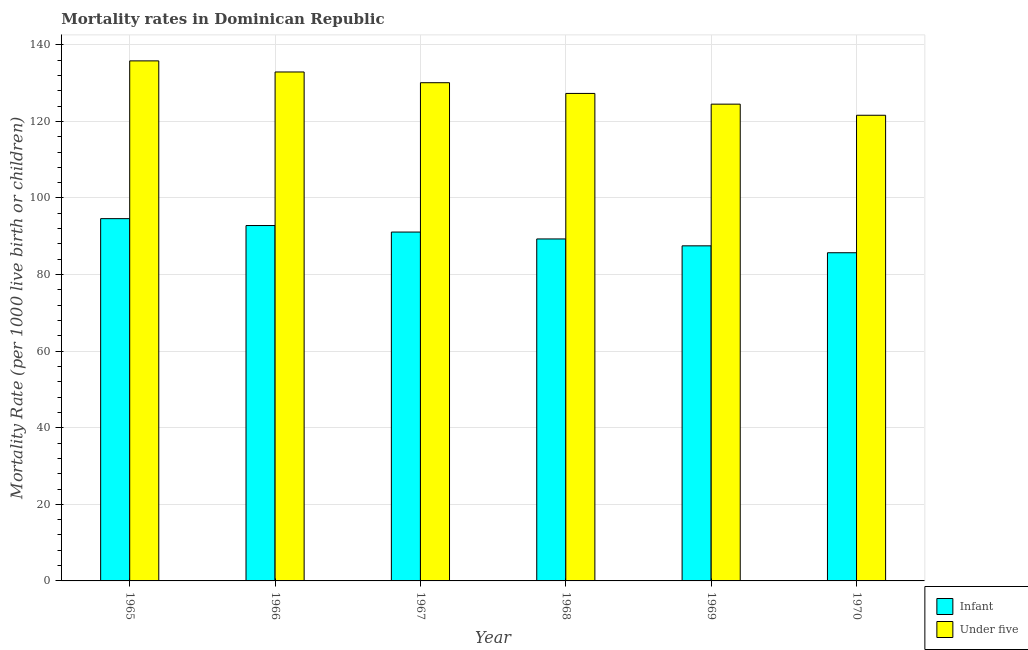How many bars are there on the 6th tick from the right?
Give a very brief answer. 2. What is the label of the 3rd group of bars from the left?
Your answer should be compact. 1967. What is the infant mortality rate in 1969?
Ensure brevity in your answer.  87.5. Across all years, what is the maximum under-5 mortality rate?
Provide a succinct answer. 135.8. Across all years, what is the minimum under-5 mortality rate?
Keep it short and to the point. 121.6. In which year was the infant mortality rate maximum?
Provide a succinct answer. 1965. What is the total under-5 mortality rate in the graph?
Offer a very short reply. 772.2. What is the difference between the under-5 mortality rate in 1966 and that in 1967?
Make the answer very short. 2.8. What is the difference between the infant mortality rate in 1966 and the under-5 mortality rate in 1967?
Offer a very short reply. 1.7. What is the average infant mortality rate per year?
Provide a succinct answer. 90.17. What is the ratio of the under-5 mortality rate in 1966 to that in 1969?
Give a very brief answer. 1.07. What is the difference between the highest and the second highest under-5 mortality rate?
Offer a very short reply. 2.9. What is the difference between the highest and the lowest infant mortality rate?
Offer a terse response. 8.9. What does the 2nd bar from the left in 1968 represents?
Provide a succinct answer. Under five. What does the 2nd bar from the right in 1966 represents?
Offer a terse response. Infant. How many years are there in the graph?
Give a very brief answer. 6. What is the difference between two consecutive major ticks on the Y-axis?
Your answer should be very brief. 20. Are the values on the major ticks of Y-axis written in scientific E-notation?
Offer a very short reply. No. Does the graph contain any zero values?
Your answer should be compact. No. Does the graph contain grids?
Offer a terse response. Yes. How many legend labels are there?
Keep it short and to the point. 2. What is the title of the graph?
Your answer should be very brief. Mortality rates in Dominican Republic. Does "Female population" appear as one of the legend labels in the graph?
Offer a very short reply. No. What is the label or title of the Y-axis?
Offer a terse response. Mortality Rate (per 1000 live birth or children). What is the Mortality Rate (per 1000 live birth or children) of Infant in 1965?
Keep it short and to the point. 94.6. What is the Mortality Rate (per 1000 live birth or children) in Under five in 1965?
Ensure brevity in your answer.  135.8. What is the Mortality Rate (per 1000 live birth or children) in Infant in 1966?
Offer a very short reply. 92.8. What is the Mortality Rate (per 1000 live birth or children) in Under five in 1966?
Offer a very short reply. 132.9. What is the Mortality Rate (per 1000 live birth or children) of Infant in 1967?
Give a very brief answer. 91.1. What is the Mortality Rate (per 1000 live birth or children) of Under five in 1967?
Provide a short and direct response. 130.1. What is the Mortality Rate (per 1000 live birth or children) of Infant in 1968?
Your answer should be compact. 89.3. What is the Mortality Rate (per 1000 live birth or children) in Under five in 1968?
Keep it short and to the point. 127.3. What is the Mortality Rate (per 1000 live birth or children) of Infant in 1969?
Keep it short and to the point. 87.5. What is the Mortality Rate (per 1000 live birth or children) in Under five in 1969?
Your answer should be compact. 124.5. What is the Mortality Rate (per 1000 live birth or children) of Infant in 1970?
Give a very brief answer. 85.7. What is the Mortality Rate (per 1000 live birth or children) in Under five in 1970?
Your answer should be very brief. 121.6. Across all years, what is the maximum Mortality Rate (per 1000 live birth or children) of Infant?
Offer a very short reply. 94.6. Across all years, what is the maximum Mortality Rate (per 1000 live birth or children) in Under five?
Make the answer very short. 135.8. Across all years, what is the minimum Mortality Rate (per 1000 live birth or children) of Infant?
Make the answer very short. 85.7. Across all years, what is the minimum Mortality Rate (per 1000 live birth or children) of Under five?
Offer a terse response. 121.6. What is the total Mortality Rate (per 1000 live birth or children) in Infant in the graph?
Your answer should be compact. 541. What is the total Mortality Rate (per 1000 live birth or children) in Under five in the graph?
Your answer should be compact. 772.2. What is the difference between the Mortality Rate (per 1000 live birth or children) of Under five in 1965 and that in 1966?
Give a very brief answer. 2.9. What is the difference between the Mortality Rate (per 1000 live birth or children) of Infant in 1965 and that in 1967?
Provide a short and direct response. 3.5. What is the difference between the Mortality Rate (per 1000 live birth or children) in Under five in 1965 and that in 1968?
Keep it short and to the point. 8.5. What is the difference between the Mortality Rate (per 1000 live birth or children) of Under five in 1965 and that in 1969?
Provide a short and direct response. 11.3. What is the difference between the Mortality Rate (per 1000 live birth or children) in Under five in 1966 and that in 1967?
Your response must be concise. 2.8. What is the difference between the Mortality Rate (per 1000 live birth or children) of Under five in 1966 and that in 1969?
Your answer should be compact. 8.4. What is the difference between the Mortality Rate (per 1000 live birth or children) in Infant in 1966 and that in 1970?
Give a very brief answer. 7.1. What is the difference between the Mortality Rate (per 1000 live birth or children) in Under five in 1966 and that in 1970?
Provide a short and direct response. 11.3. What is the difference between the Mortality Rate (per 1000 live birth or children) of Infant in 1967 and that in 1968?
Your answer should be compact. 1.8. What is the difference between the Mortality Rate (per 1000 live birth or children) of Under five in 1967 and that in 1968?
Your answer should be compact. 2.8. What is the difference between the Mortality Rate (per 1000 live birth or children) of Infant in 1967 and that in 1970?
Make the answer very short. 5.4. What is the difference between the Mortality Rate (per 1000 live birth or children) in Under five in 1967 and that in 1970?
Ensure brevity in your answer.  8.5. What is the difference between the Mortality Rate (per 1000 live birth or children) in Infant in 1968 and that in 1969?
Make the answer very short. 1.8. What is the difference between the Mortality Rate (per 1000 live birth or children) in Infant in 1968 and that in 1970?
Offer a terse response. 3.6. What is the difference between the Mortality Rate (per 1000 live birth or children) of Infant in 1969 and that in 1970?
Your response must be concise. 1.8. What is the difference between the Mortality Rate (per 1000 live birth or children) of Under five in 1969 and that in 1970?
Provide a short and direct response. 2.9. What is the difference between the Mortality Rate (per 1000 live birth or children) in Infant in 1965 and the Mortality Rate (per 1000 live birth or children) in Under five in 1966?
Provide a short and direct response. -38.3. What is the difference between the Mortality Rate (per 1000 live birth or children) in Infant in 1965 and the Mortality Rate (per 1000 live birth or children) in Under five in 1967?
Make the answer very short. -35.5. What is the difference between the Mortality Rate (per 1000 live birth or children) of Infant in 1965 and the Mortality Rate (per 1000 live birth or children) of Under five in 1968?
Your answer should be very brief. -32.7. What is the difference between the Mortality Rate (per 1000 live birth or children) of Infant in 1965 and the Mortality Rate (per 1000 live birth or children) of Under five in 1969?
Your response must be concise. -29.9. What is the difference between the Mortality Rate (per 1000 live birth or children) in Infant in 1966 and the Mortality Rate (per 1000 live birth or children) in Under five in 1967?
Your answer should be very brief. -37.3. What is the difference between the Mortality Rate (per 1000 live birth or children) in Infant in 1966 and the Mortality Rate (per 1000 live birth or children) in Under five in 1968?
Keep it short and to the point. -34.5. What is the difference between the Mortality Rate (per 1000 live birth or children) in Infant in 1966 and the Mortality Rate (per 1000 live birth or children) in Under five in 1969?
Offer a terse response. -31.7. What is the difference between the Mortality Rate (per 1000 live birth or children) in Infant in 1966 and the Mortality Rate (per 1000 live birth or children) in Under five in 1970?
Provide a short and direct response. -28.8. What is the difference between the Mortality Rate (per 1000 live birth or children) of Infant in 1967 and the Mortality Rate (per 1000 live birth or children) of Under five in 1968?
Make the answer very short. -36.2. What is the difference between the Mortality Rate (per 1000 live birth or children) in Infant in 1967 and the Mortality Rate (per 1000 live birth or children) in Under five in 1969?
Offer a very short reply. -33.4. What is the difference between the Mortality Rate (per 1000 live birth or children) of Infant in 1967 and the Mortality Rate (per 1000 live birth or children) of Under five in 1970?
Give a very brief answer. -30.5. What is the difference between the Mortality Rate (per 1000 live birth or children) of Infant in 1968 and the Mortality Rate (per 1000 live birth or children) of Under five in 1969?
Provide a succinct answer. -35.2. What is the difference between the Mortality Rate (per 1000 live birth or children) of Infant in 1968 and the Mortality Rate (per 1000 live birth or children) of Under five in 1970?
Keep it short and to the point. -32.3. What is the difference between the Mortality Rate (per 1000 live birth or children) of Infant in 1969 and the Mortality Rate (per 1000 live birth or children) of Under five in 1970?
Give a very brief answer. -34.1. What is the average Mortality Rate (per 1000 live birth or children) in Infant per year?
Your response must be concise. 90.17. What is the average Mortality Rate (per 1000 live birth or children) in Under five per year?
Ensure brevity in your answer.  128.7. In the year 1965, what is the difference between the Mortality Rate (per 1000 live birth or children) of Infant and Mortality Rate (per 1000 live birth or children) of Under five?
Provide a succinct answer. -41.2. In the year 1966, what is the difference between the Mortality Rate (per 1000 live birth or children) in Infant and Mortality Rate (per 1000 live birth or children) in Under five?
Your answer should be very brief. -40.1. In the year 1967, what is the difference between the Mortality Rate (per 1000 live birth or children) of Infant and Mortality Rate (per 1000 live birth or children) of Under five?
Give a very brief answer. -39. In the year 1968, what is the difference between the Mortality Rate (per 1000 live birth or children) in Infant and Mortality Rate (per 1000 live birth or children) in Under five?
Provide a short and direct response. -38. In the year 1969, what is the difference between the Mortality Rate (per 1000 live birth or children) of Infant and Mortality Rate (per 1000 live birth or children) of Under five?
Offer a very short reply. -37. In the year 1970, what is the difference between the Mortality Rate (per 1000 live birth or children) in Infant and Mortality Rate (per 1000 live birth or children) in Under five?
Offer a very short reply. -35.9. What is the ratio of the Mortality Rate (per 1000 live birth or children) in Infant in 1965 to that in 1966?
Keep it short and to the point. 1.02. What is the ratio of the Mortality Rate (per 1000 live birth or children) of Under five in 1965 to that in 1966?
Your answer should be very brief. 1.02. What is the ratio of the Mortality Rate (per 1000 live birth or children) of Infant in 1965 to that in 1967?
Ensure brevity in your answer.  1.04. What is the ratio of the Mortality Rate (per 1000 live birth or children) of Under five in 1965 to that in 1967?
Your answer should be compact. 1.04. What is the ratio of the Mortality Rate (per 1000 live birth or children) of Infant in 1965 to that in 1968?
Make the answer very short. 1.06. What is the ratio of the Mortality Rate (per 1000 live birth or children) of Under five in 1965 to that in 1968?
Your response must be concise. 1.07. What is the ratio of the Mortality Rate (per 1000 live birth or children) of Infant in 1965 to that in 1969?
Ensure brevity in your answer.  1.08. What is the ratio of the Mortality Rate (per 1000 live birth or children) in Under five in 1965 to that in 1969?
Your answer should be very brief. 1.09. What is the ratio of the Mortality Rate (per 1000 live birth or children) of Infant in 1965 to that in 1970?
Provide a short and direct response. 1.1. What is the ratio of the Mortality Rate (per 1000 live birth or children) of Under five in 1965 to that in 1970?
Provide a short and direct response. 1.12. What is the ratio of the Mortality Rate (per 1000 live birth or children) in Infant in 1966 to that in 1967?
Offer a very short reply. 1.02. What is the ratio of the Mortality Rate (per 1000 live birth or children) of Under five in 1966 to that in 1967?
Keep it short and to the point. 1.02. What is the ratio of the Mortality Rate (per 1000 live birth or children) of Infant in 1966 to that in 1968?
Your answer should be very brief. 1.04. What is the ratio of the Mortality Rate (per 1000 live birth or children) in Under five in 1966 to that in 1968?
Make the answer very short. 1.04. What is the ratio of the Mortality Rate (per 1000 live birth or children) in Infant in 1966 to that in 1969?
Your answer should be compact. 1.06. What is the ratio of the Mortality Rate (per 1000 live birth or children) in Under five in 1966 to that in 1969?
Give a very brief answer. 1.07. What is the ratio of the Mortality Rate (per 1000 live birth or children) in Infant in 1966 to that in 1970?
Provide a succinct answer. 1.08. What is the ratio of the Mortality Rate (per 1000 live birth or children) in Under five in 1966 to that in 1970?
Offer a very short reply. 1.09. What is the ratio of the Mortality Rate (per 1000 live birth or children) in Infant in 1967 to that in 1968?
Your answer should be very brief. 1.02. What is the ratio of the Mortality Rate (per 1000 live birth or children) in Infant in 1967 to that in 1969?
Offer a very short reply. 1.04. What is the ratio of the Mortality Rate (per 1000 live birth or children) of Under five in 1967 to that in 1969?
Offer a very short reply. 1.04. What is the ratio of the Mortality Rate (per 1000 live birth or children) in Infant in 1967 to that in 1970?
Your answer should be compact. 1.06. What is the ratio of the Mortality Rate (per 1000 live birth or children) in Under five in 1967 to that in 1970?
Your response must be concise. 1.07. What is the ratio of the Mortality Rate (per 1000 live birth or children) in Infant in 1968 to that in 1969?
Keep it short and to the point. 1.02. What is the ratio of the Mortality Rate (per 1000 live birth or children) of Under five in 1968 to that in 1969?
Offer a very short reply. 1.02. What is the ratio of the Mortality Rate (per 1000 live birth or children) in Infant in 1968 to that in 1970?
Offer a very short reply. 1.04. What is the ratio of the Mortality Rate (per 1000 live birth or children) in Under five in 1968 to that in 1970?
Provide a succinct answer. 1.05. What is the ratio of the Mortality Rate (per 1000 live birth or children) of Infant in 1969 to that in 1970?
Keep it short and to the point. 1.02. What is the ratio of the Mortality Rate (per 1000 live birth or children) of Under five in 1969 to that in 1970?
Offer a very short reply. 1.02. 